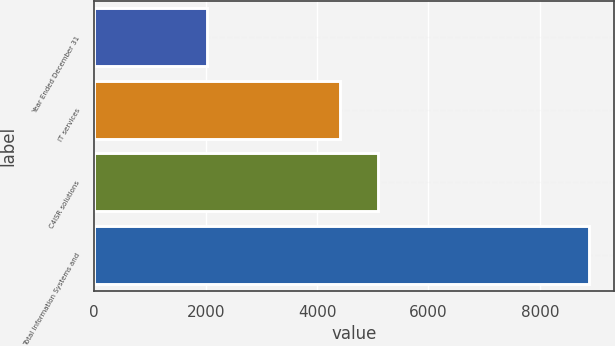Convert chart. <chart><loc_0><loc_0><loc_500><loc_500><bar_chart><fcel>Year Ended December 31<fcel>IT services<fcel>C4ISR solutions<fcel>Total Information Systems and<nl><fcel>2017<fcel>4410<fcel>5097.4<fcel>8891<nl></chart> 